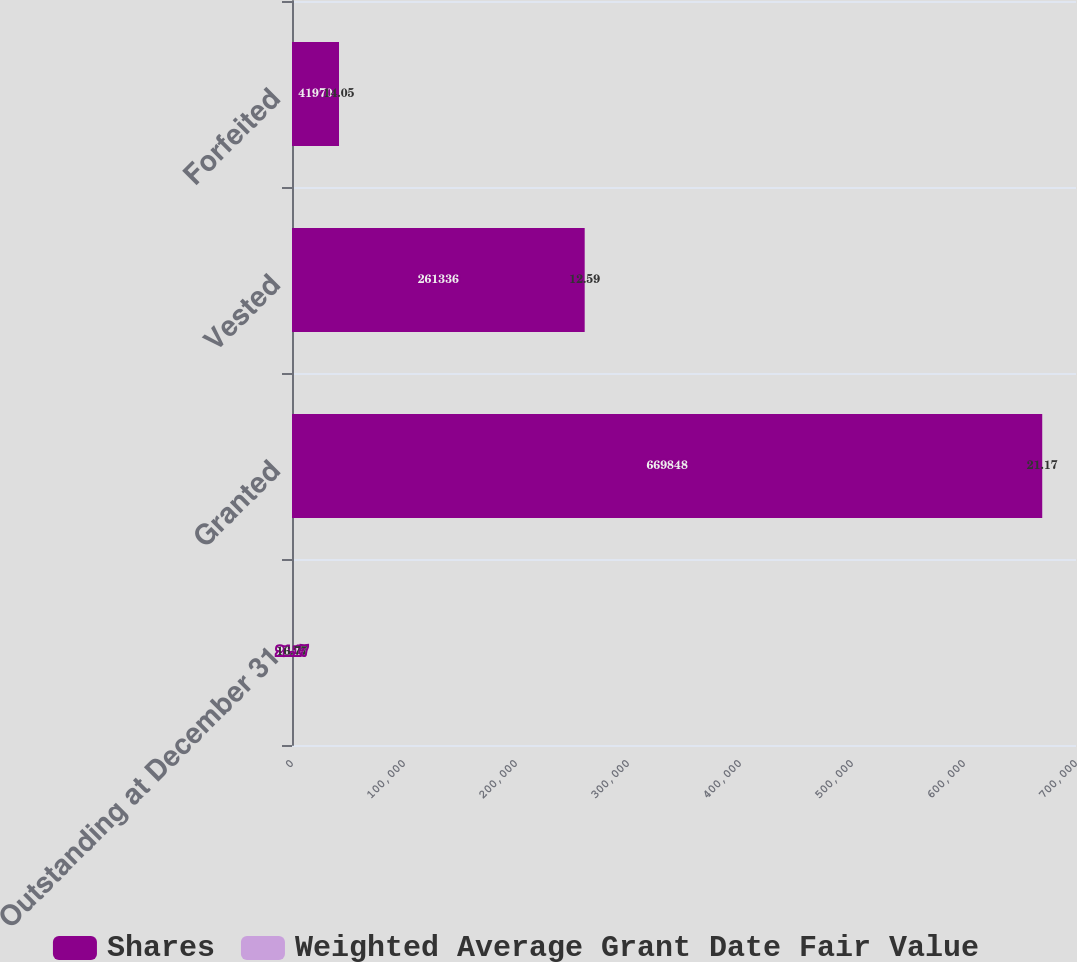Convert chart. <chart><loc_0><loc_0><loc_500><loc_500><stacked_bar_chart><ecel><fcel>Outstanding at December 31<fcel>Granted<fcel>Vested<fcel>Forfeited<nl><fcel>Shares<fcel>21.17<fcel>669848<fcel>261336<fcel>41970<nl><fcel>Weighted Average Grant Date Fair Value<fcel>16.77<fcel>21.17<fcel>12.59<fcel>14.05<nl></chart> 